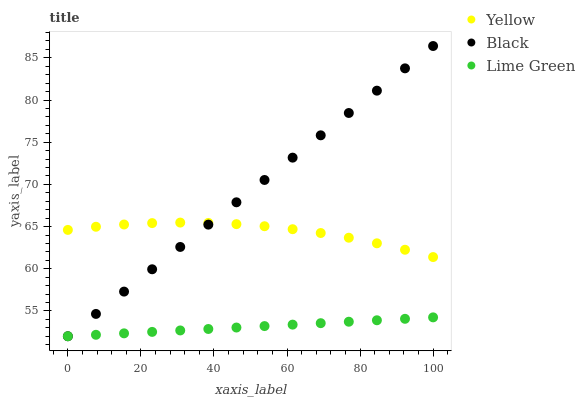Does Lime Green have the minimum area under the curve?
Answer yes or no. Yes. Does Black have the maximum area under the curve?
Answer yes or no. Yes. Does Yellow have the minimum area under the curve?
Answer yes or no. No. Does Yellow have the maximum area under the curve?
Answer yes or no. No. Is Lime Green the smoothest?
Answer yes or no. Yes. Is Yellow the roughest?
Answer yes or no. Yes. Is Black the smoothest?
Answer yes or no. No. Is Black the roughest?
Answer yes or no. No. Does Lime Green have the lowest value?
Answer yes or no. Yes. Does Yellow have the lowest value?
Answer yes or no. No. Does Black have the highest value?
Answer yes or no. Yes. Does Yellow have the highest value?
Answer yes or no. No. Is Lime Green less than Yellow?
Answer yes or no. Yes. Is Yellow greater than Lime Green?
Answer yes or no. Yes. Does Black intersect Lime Green?
Answer yes or no. Yes. Is Black less than Lime Green?
Answer yes or no. No. Is Black greater than Lime Green?
Answer yes or no. No. Does Lime Green intersect Yellow?
Answer yes or no. No. 